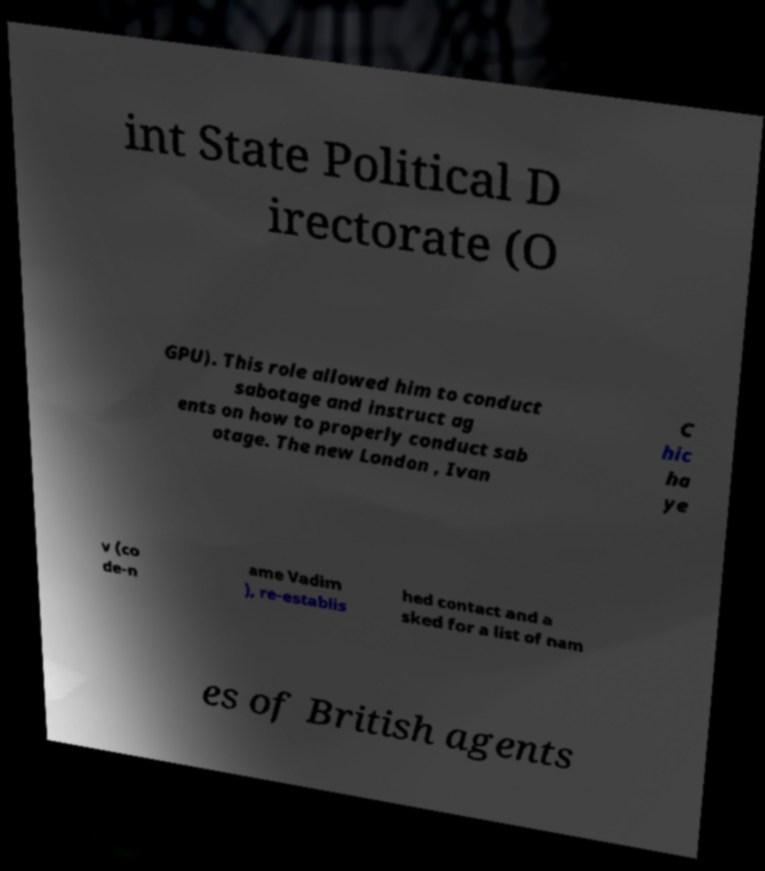Can you read and provide the text displayed in the image?This photo seems to have some interesting text. Can you extract and type it out for me? int State Political D irectorate (O GPU). This role allowed him to conduct sabotage and instruct ag ents on how to properly conduct sab otage. The new London , Ivan C hic ha ye v (co de-n ame Vadim ), re-establis hed contact and a sked for a list of nam es of British agents 